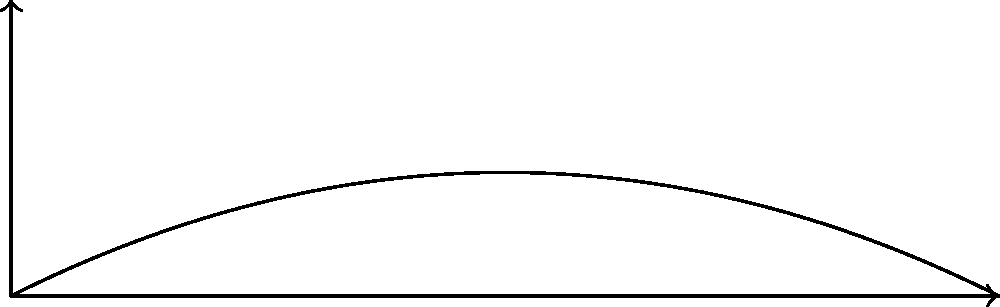A baseball pitcher throws a ball, and its trajectory is shown in the graph above. The red arrows represent velocity vectors at two different points along the path. How does the magnitude of the velocity vector $\vec{v_2}$ compare to $\vec{v_1}$, and why? To answer this question, let's analyze the trajectory and velocity vectors step-by-step:

1. The trajectory of the ball forms a parabolic path, which is typical for projectile motion under the influence of gravity.

2. The apex (highest point) of the trajectory is marked on the graph.

3. $\vec{v_1}$ is located before the apex, while $\vec{v_2}$ is located after the apex.

4. In projectile motion, the total velocity can be decomposed into horizontal and vertical components:
   $\vec{v} = \vec{v_x} + \vec{v_y}$

5. The horizontal component of velocity ($\vec{v_x}$) remains constant throughout the motion due to the absence of horizontal forces (ignoring air resistance).

6. The vertical component of velocity ($\vec{v_y}$) changes due to gravity:
   - It decreases as the ball rises towards the apex.
   - It becomes zero at the apex.
   - It increases as the ball falls from the apex.

7. $\vec{v_1}$ has both positive horizontal and vertical components, as the ball is still rising.

8. $\vec{v_2}$ has a positive horizontal component (same as $\vec{v_1}$) and a negative vertical component, as the ball is falling.

9. The magnitude of a vector is given by $|\vec{v}| = \sqrt{v_x^2 + v_y^2}$

10. Since $\vec{v_2}$ is further from the apex than $\vec{v_1}$, its vertical component has a larger magnitude due to the acceleration of gravity.

Therefore, the magnitude of $\vec{v_2}$ is greater than the magnitude of $\vec{v_1}$.
Answer: $|\vec{v_2}| > |\vec{v_1}|$ due to increased vertical velocity component after apex. 